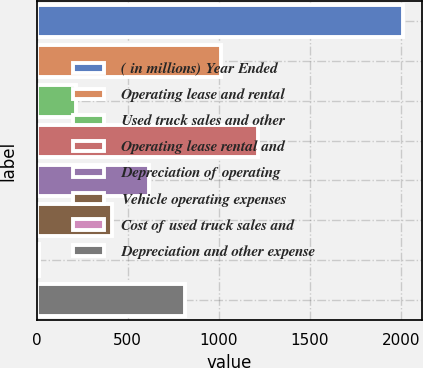Convert chart to OTSL. <chart><loc_0><loc_0><loc_500><loc_500><bar_chart><fcel>( in millions) Year Ended<fcel>Operating lease and rental<fcel>Used truck sales and other<fcel>Operating lease rental and<fcel>Depreciation of operating<fcel>Vehicle operating expenses<fcel>Cost of used truck sales and<fcel>Depreciation and other expense<nl><fcel>2014<fcel>1014.8<fcel>215.44<fcel>1214.64<fcel>615.12<fcel>415.28<fcel>15.6<fcel>814.96<nl></chart> 